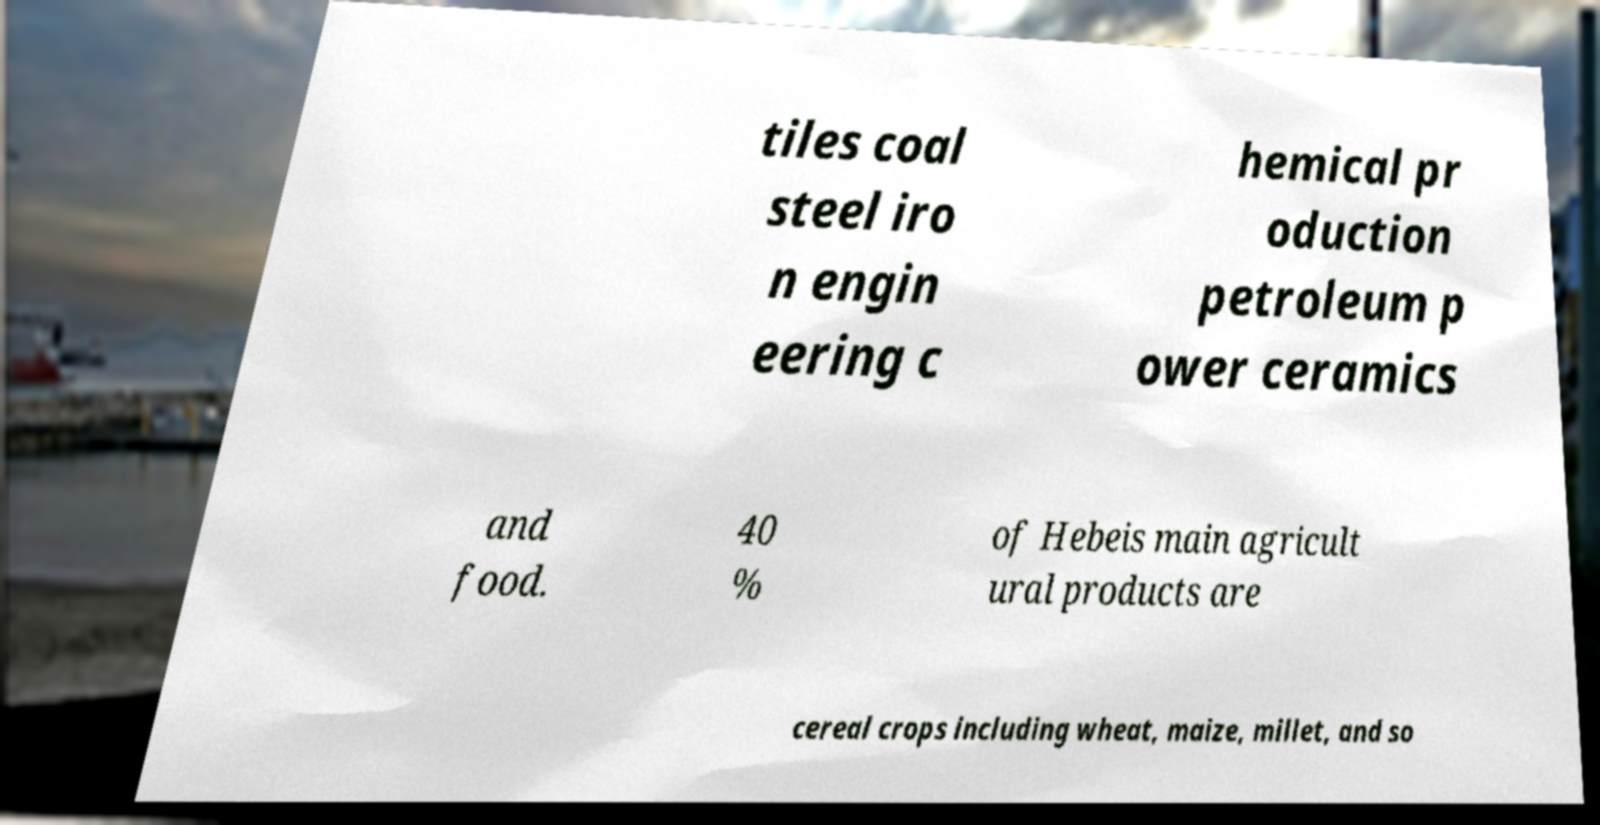Please read and relay the text visible in this image. What does it say? tiles coal steel iro n engin eering c hemical pr oduction petroleum p ower ceramics and food. 40 % of Hebeis main agricult ural products are cereal crops including wheat, maize, millet, and so 